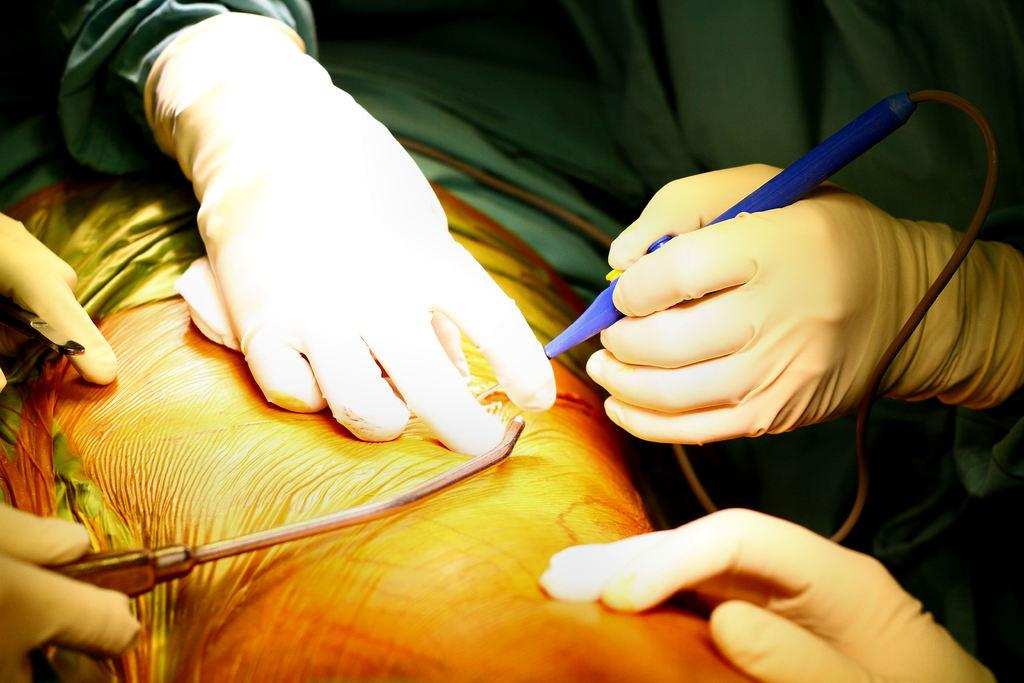What body part is visible in the image? There is a person's thigh in the image. What are the two persons doing in the image? They are holding a device and tool in the image. Can you describe the fingers visible at the bottom of the image? Fingers are visible at the bottom of the image. What type of leather material is present on the desk in the image? There is no desk or leather material present in the image. 